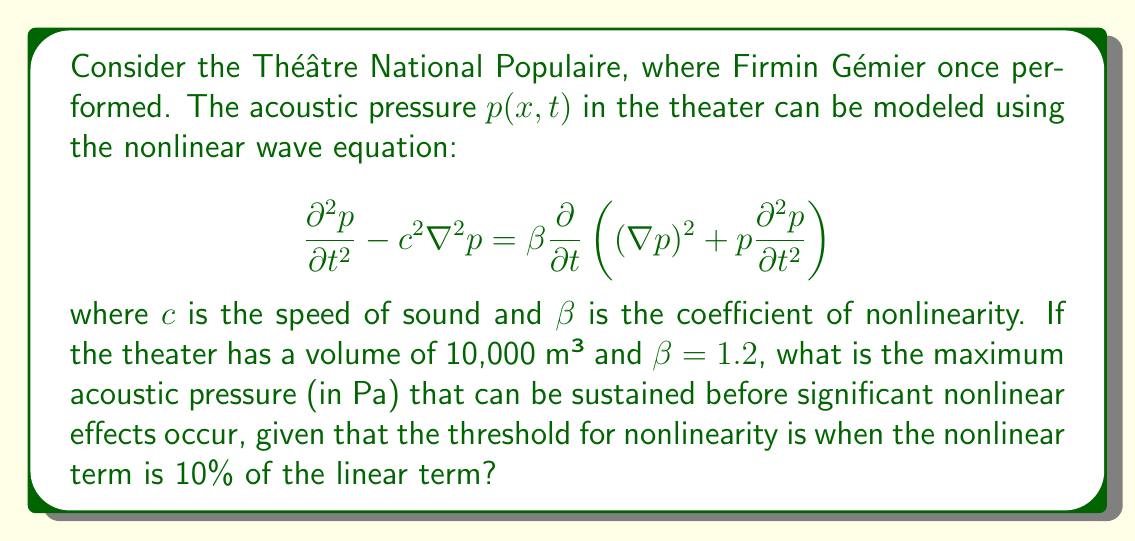Can you answer this question? To solve this problem, we need to compare the linear and nonlinear terms in the wave equation:

1) The linear term is $c^2\nabla^2 p$, which scales as $c^2 p / L^2$, where $L$ is a characteristic length of the theater.

2) The nonlinear term scales as $\beta p \partial^2 p / \partial t^2$, which is approximately $\beta \omega^2 p^2$, where $\omega$ is the angular frequency of the sound.

3) The threshold for nonlinearity occurs when the nonlinear term is 10% of the linear term:

   $$0.1 \cdot \frac{c^2 p}{L^2} = \beta \omega^2 p^2$$

4) We can estimate $L$ from the theater volume $V$:
   
   $$L = V^{1/3} = (10,000 \text{ m}^3)^{1/3} \approx 21.5 \text{ m}$$

5) The angular frequency $\omega$ can be estimated using the typical range of human hearing, say 1 kHz:

   $$\omega = 2\pi f = 2\pi \cdot 1000 \approx 6280 \text{ rad/s}$$

6) Substituting these values into the equation from step 3:

   $$0.1 \cdot \frac{(343 \text{ m/s})^2 p}{(21.5 \text{ m})^2} = 1.2 \cdot (6280 \text{ rad/s})^2 p^2$$

7) Simplifying:

   $$2.54 \cdot 10^4 \text{ Pa} = 4.73 \cdot 10^7 p$$

8) Solving for $p$:

   $$p = \frac{2.54 \cdot 10^4}{4.73 \cdot 10^7} \approx 0.537 \text{ Pa}$$

This is the maximum acoustic pressure before significant nonlinear effects occur.
Answer: 0.537 Pa 